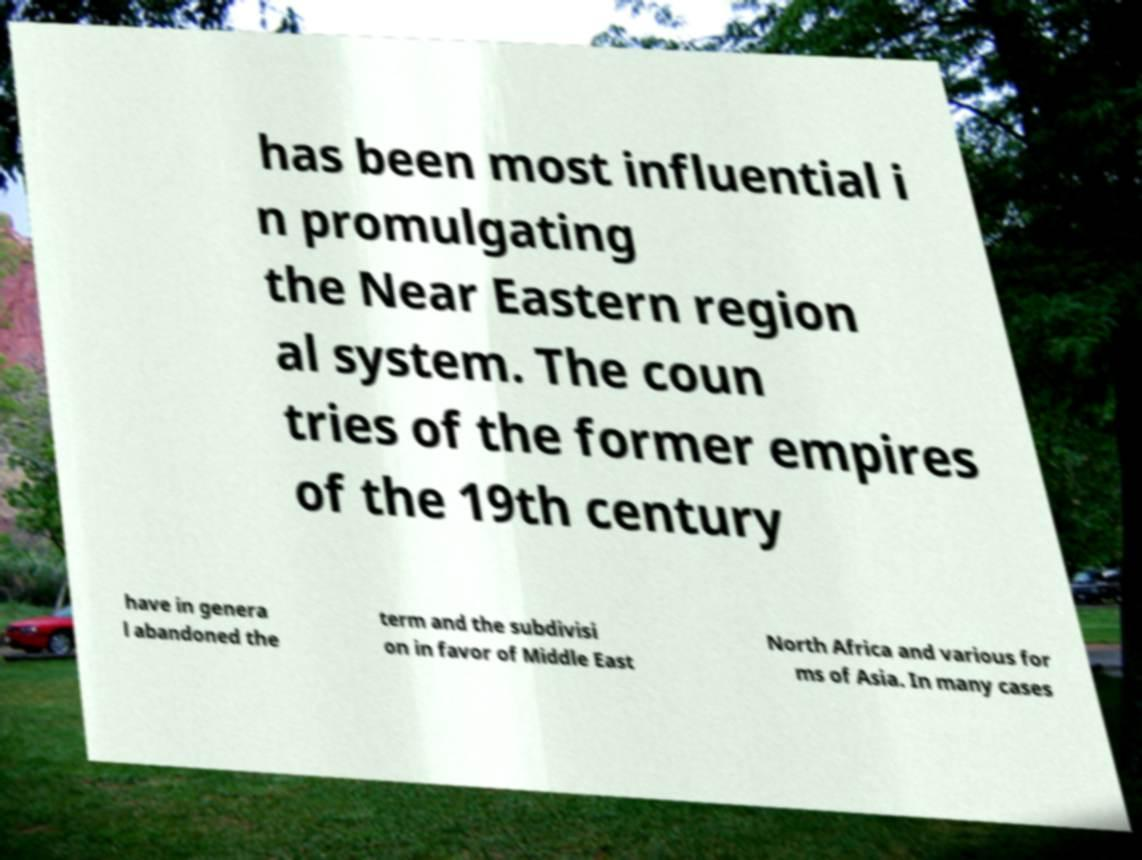What messages or text are displayed in this image? I need them in a readable, typed format. has been most influential i n promulgating the Near Eastern region al system. The coun tries of the former empires of the 19th century have in genera l abandoned the term and the subdivisi on in favor of Middle East North Africa and various for ms of Asia. In many cases 